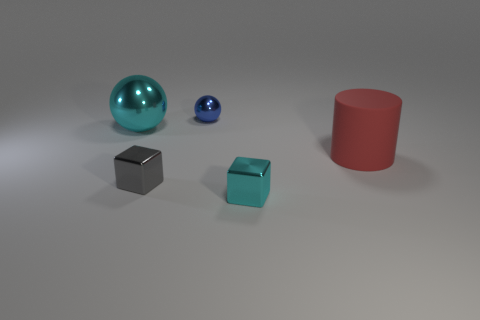Add 3 small blue shiny balls. How many objects exist? 8 Subtract all blocks. How many objects are left? 3 Subtract 0 red blocks. How many objects are left? 5 Subtract all large cyan balls. Subtract all cyan shiny objects. How many objects are left? 2 Add 1 tiny gray metal cubes. How many tiny gray metal cubes are left? 2 Add 2 small cubes. How many small cubes exist? 4 